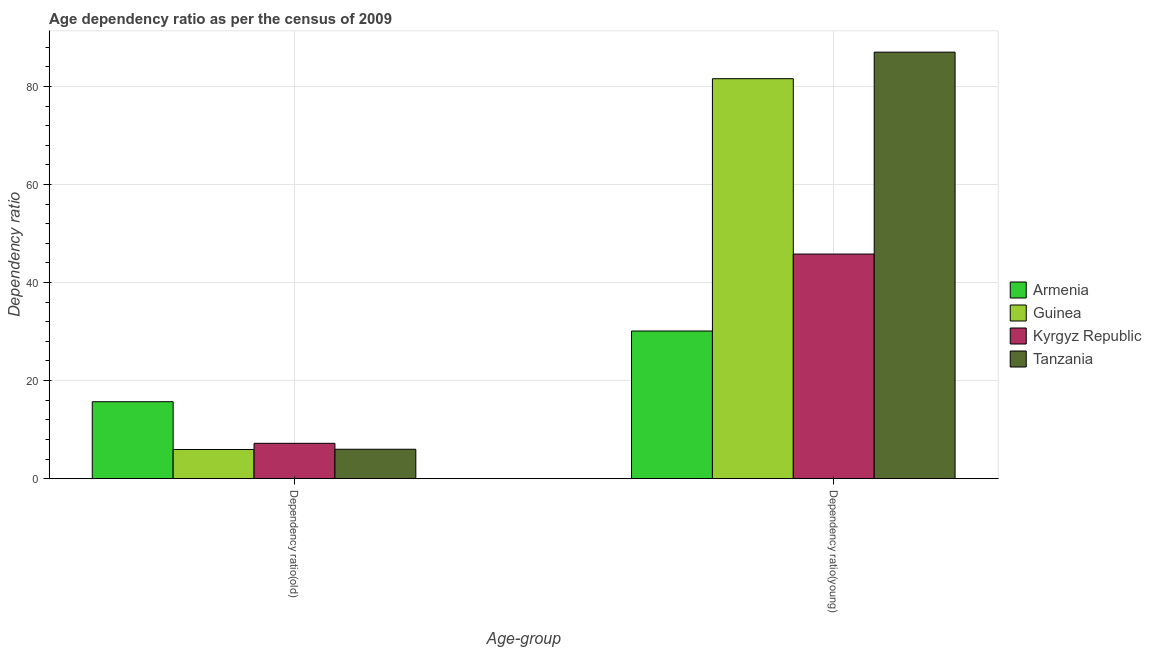How many different coloured bars are there?
Keep it short and to the point. 4. How many bars are there on the 2nd tick from the left?
Your answer should be compact. 4. How many bars are there on the 2nd tick from the right?
Your answer should be compact. 4. What is the label of the 1st group of bars from the left?
Offer a terse response. Dependency ratio(old). What is the age dependency ratio(old) in Tanzania?
Your answer should be very brief. 5.99. Across all countries, what is the maximum age dependency ratio(young)?
Offer a very short reply. 86.98. Across all countries, what is the minimum age dependency ratio(old)?
Provide a succinct answer. 5.93. In which country was the age dependency ratio(young) maximum?
Provide a short and direct response. Tanzania. In which country was the age dependency ratio(young) minimum?
Give a very brief answer. Armenia. What is the total age dependency ratio(old) in the graph?
Offer a very short reply. 34.8. What is the difference between the age dependency ratio(old) in Armenia and that in Guinea?
Keep it short and to the point. 9.75. What is the difference between the age dependency ratio(young) in Tanzania and the age dependency ratio(old) in Kyrgyz Republic?
Your answer should be compact. 79.78. What is the average age dependency ratio(old) per country?
Your answer should be compact. 8.7. What is the difference between the age dependency ratio(young) and age dependency ratio(old) in Armenia?
Keep it short and to the point. 14.42. In how many countries, is the age dependency ratio(old) greater than 44 ?
Make the answer very short. 0. What is the ratio of the age dependency ratio(old) in Tanzania to that in Armenia?
Your response must be concise. 0.38. What does the 2nd bar from the left in Dependency ratio(old) represents?
Provide a short and direct response. Guinea. What does the 4th bar from the right in Dependency ratio(young) represents?
Make the answer very short. Armenia. How many bars are there?
Your response must be concise. 8. Are all the bars in the graph horizontal?
Your response must be concise. No. What is the difference between two consecutive major ticks on the Y-axis?
Your response must be concise. 20. Does the graph contain any zero values?
Keep it short and to the point. No. Where does the legend appear in the graph?
Offer a very short reply. Center right. What is the title of the graph?
Your response must be concise. Age dependency ratio as per the census of 2009. What is the label or title of the X-axis?
Make the answer very short. Age-group. What is the label or title of the Y-axis?
Offer a very short reply. Dependency ratio. What is the Dependency ratio in Armenia in Dependency ratio(old)?
Offer a terse response. 15.68. What is the Dependency ratio in Guinea in Dependency ratio(old)?
Provide a succinct answer. 5.93. What is the Dependency ratio in Kyrgyz Republic in Dependency ratio(old)?
Ensure brevity in your answer.  7.2. What is the Dependency ratio of Tanzania in Dependency ratio(old)?
Your answer should be compact. 5.99. What is the Dependency ratio in Armenia in Dependency ratio(young)?
Ensure brevity in your answer.  30.1. What is the Dependency ratio in Guinea in Dependency ratio(young)?
Give a very brief answer. 81.57. What is the Dependency ratio in Kyrgyz Republic in Dependency ratio(young)?
Give a very brief answer. 45.8. What is the Dependency ratio of Tanzania in Dependency ratio(young)?
Offer a very short reply. 86.98. Across all Age-group, what is the maximum Dependency ratio of Armenia?
Give a very brief answer. 30.1. Across all Age-group, what is the maximum Dependency ratio in Guinea?
Make the answer very short. 81.57. Across all Age-group, what is the maximum Dependency ratio in Kyrgyz Republic?
Give a very brief answer. 45.8. Across all Age-group, what is the maximum Dependency ratio in Tanzania?
Ensure brevity in your answer.  86.98. Across all Age-group, what is the minimum Dependency ratio in Armenia?
Make the answer very short. 15.68. Across all Age-group, what is the minimum Dependency ratio of Guinea?
Offer a very short reply. 5.93. Across all Age-group, what is the minimum Dependency ratio of Kyrgyz Republic?
Your response must be concise. 7.2. Across all Age-group, what is the minimum Dependency ratio in Tanzania?
Make the answer very short. 5.99. What is the total Dependency ratio in Armenia in the graph?
Your response must be concise. 45.79. What is the total Dependency ratio of Guinea in the graph?
Your answer should be very brief. 87.5. What is the total Dependency ratio in Kyrgyz Republic in the graph?
Provide a succinct answer. 53. What is the total Dependency ratio of Tanzania in the graph?
Provide a short and direct response. 92.97. What is the difference between the Dependency ratio in Armenia in Dependency ratio(old) and that in Dependency ratio(young)?
Ensure brevity in your answer.  -14.42. What is the difference between the Dependency ratio in Guinea in Dependency ratio(old) and that in Dependency ratio(young)?
Ensure brevity in your answer.  -75.64. What is the difference between the Dependency ratio of Kyrgyz Republic in Dependency ratio(old) and that in Dependency ratio(young)?
Offer a very short reply. -38.6. What is the difference between the Dependency ratio of Tanzania in Dependency ratio(old) and that in Dependency ratio(young)?
Ensure brevity in your answer.  -81. What is the difference between the Dependency ratio in Armenia in Dependency ratio(old) and the Dependency ratio in Guinea in Dependency ratio(young)?
Provide a short and direct response. -65.88. What is the difference between the Dependency ratio of Armenia in Dependency ratio(old) and the Dependency ratio of Kyrgyz Republic in Dependency ratio(young)?
Give a very brief answer. -30.12. What is the difference between the Dependency ratio of Armenia in Dependency ratio(old) and the Dependency ratio of Tanzania in Dependency ratio(young)?
Offer a terse response. -71.3. What is the difference between the Dependency ratio of Guinea in Dependency ratio(old) and the Dependency ratio of Kyrgyz Republic in Dependency ratio(young)?
Your response must be concise. -39.87. What is the difference between the Dependency ratio of Guinea in Dependency ratio(old) and the Dependency ratio of Tanzania in Dependency ratio(young)?
Keep it short and to the point. -81.05. What is the difference between the Dependency ratio of Kyrgyz Republic in Dependency ratio(old) and the Dependency ratio of Tanzania in Dependency ratio(young)?
Make the answer very short. -79.78. What is the average Dependency ratio of Armenia per Age-group?
Your answer should be compact. 22.89. What is the average Dependency ratio of Guinea per Age-group?
Your response must be concise. 43.75. What is the average Dependency ratio in Kyrgyz Republic per Age-group?
Make the answer very short. 26.5. What is the average Dependency ratio in Tanzania per Age-group?
Provide a short and direct response. 46.49. What is the difference between the Dependency ratio in Armenia and Dependency ratio in Guinea in Dependency ratio(old)?
Give a very brief answer. 9.75. What is the difference between the Dependency ratio in Armenia and Dependency ratio in Kyrgyz Republic in Dependency ratio(old)?
Keep it short and to the point. 8.49. What is the difference between the Dependency ratio of Armenia and Dependency ratio of Tanzania in Dependency ratio(old)?
Keep it short and to the point. 9.7. What is the difference between the Dependency ratio in Guinea and Dependency ratio in Kyrgyz Republic in Dependency ratio(old)?
Ensure brevity in your answer.  -1.27. What is the difference between the Dependency ratio of Guinea and Dependency ratio of Tanzania in Dependency ratio(old)?
Provide a succinct answer. -0.05. What is the difference between the Dependency ratio in Kyrgyz Republic and Dependency ratio in Tanzania in Dependency ratio(old)?
Offer a terse response. 1.21. What is the difference between the Dependency ratio in Armenia and Dependency ratio in Guinea in Dependency ratio(young)?
Give a very brief answer. -51.46. What is the difference between the Dependency ratio of Armenia and Dependency ratio of Kyrgyz Republic in Dependency ratio(young)?
Your response must be concise. -15.7. What is the difference between the Dependency ratio in Armenia and Dependency ratio in Tanzania in Dependency ratio(young)?
Keep it short and to the point. -56.88. What is the difference between the Dependency ratio of Guinea and Dependency ratio of Kyrgyz Republic in Dependency ratio(young)?
Give a very brief answer. 35.77. What is the difference between the Dependency ratio in Guinea and Dependency ratio in Tanzania in Dependency ratio(young)?
Give a very brief answer. -5.42. What is the difference between the Dependency ratio of Kyrgyz Republic and Dependency ratio of Tanzania in Dependency ratio(young)?
Provide a short and direct response. -41.18. What is the ratio of the Dependency ratio in Armenia in Dependency ratio(old) to that in Dependency ratio(young)?
Your answer should be compact. 0.52. What is the ratio of the Dependency ratio of Guinea in Dependency ratio(old) to that in Dependency ratio(young)?
Ensure brevity in your answer.  0.07. What is the ratio of the Dependency ratio of Kyrgyz Republic in Dependency ratio(old) to that in Dependency ratio(young)?
Make the answer very short. 0.16. What is the ratio of the Dependency ratio of Tanzania in Dependency ratio(old) to that in Dependency ratio(young)?
Offer a very short reply. 0.07. What is the difference between the highest and the second highest Dependency ratio of Armenia?
Your response must be concise. 14.42. What is the difference between the highest and the second highest Dependency ratio in Guinea?
Your answer should be very brief. 75.64. What is the difference between the highest and the second highest Dependency ratio of Kyrgyz Republic?
Your answer should be compact. 38.6. What is the difference between the highest and the second highest Dependency ratio of Tanzania?
Provide a succinct answer. 81. What is the difference between the highest and the lowest Dependency ratio of Armenia?
Make the answer very short. 14.42. What is the difference between the highest and the lowest Dependency ratio of Guinea?
Keep it short and to the point. 75.64. What is the difference between the highest and the lowest Dependency ratio of Kyrgyz Republic?
Make the answer very short. 38.6. What is the difference between the highest and the lowest Dependency ratio of Tanzania?
Offer a very short reply. 81. 